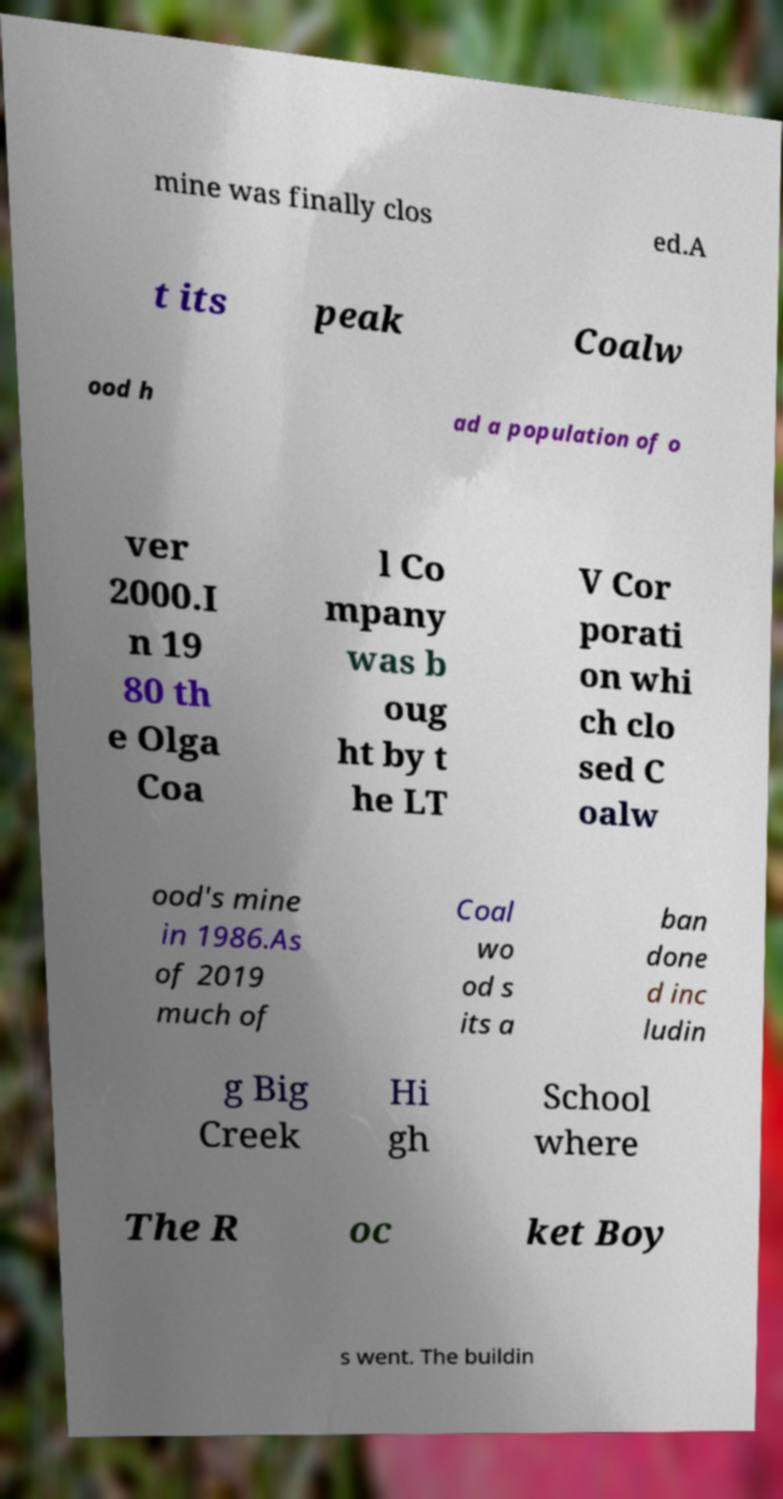There's text embedded in this image that I need extracted. Can you transcribe it verbatim? mine was finally clos ed.A t its peak Coalw ood h ad a population of o ver 2000.I n 19 80 th e Olga Coa l Co mpany was b oug ht by t he LT V Cor porati on whi ch clo sed C oalw ood's mine in 1986.As of 2019 much of Coal wo od s its a ban done d inc ludin g Big Creek Hi gh School where The R oc ket Boy s went. The buildin 